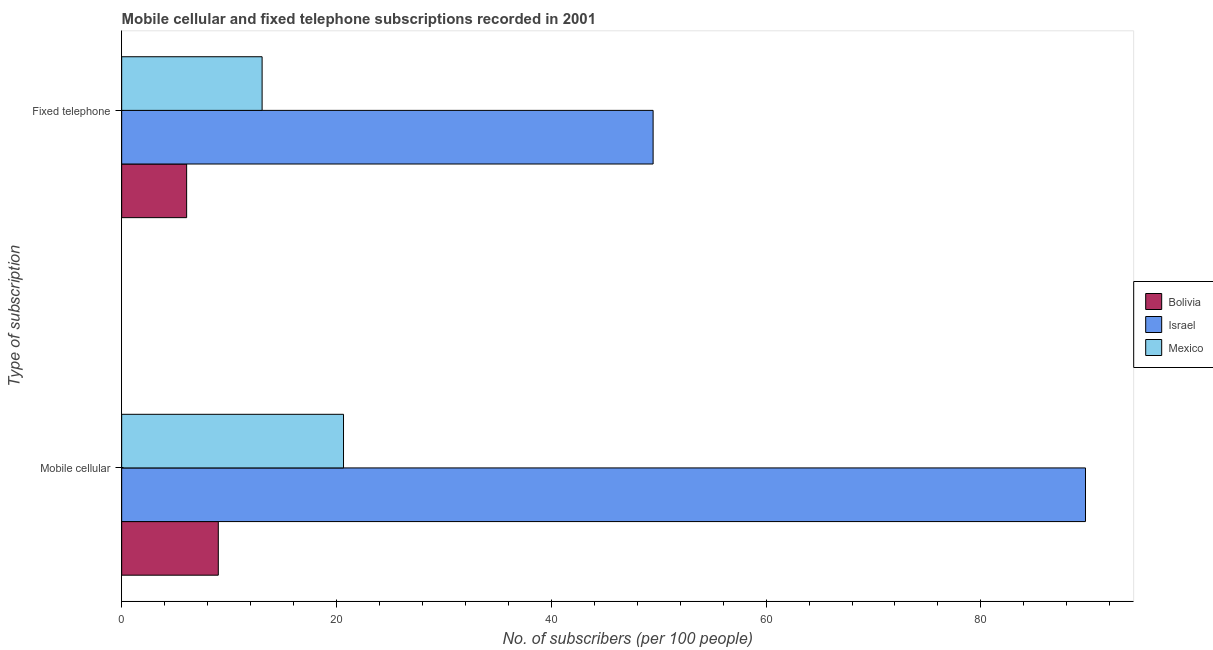How many groups of bars are there?
Your response must be concise. 2. Are the number of bars on each tick of the Y-axis equal?
Your answer should be compact. Yes. How many bars are there on the 1st tick from the top?
Offer a very short reply. 3. What is the label of the 2nd group of bars from the top?
Offer a terse response. Mobile cellular. What is the number of fixed telephone subscribers in Bolivia?
Provide a short and direct response. 6.05. Across all countries, what is the maximum number of fixed telephone subscribers?
Give a very brief answer. 49.48. Across all countries, what is the minimum number of mobile cellular subscribers?
Keep it short and to the point. 9. In which country was the number of fixed telephone subscribers maximum?
Your answer should be very brief. Israel. In which country was the number of fixed telephone subscribers minimum?
Make the answer very short. Bolivia. What is the total number of fixed telephone subscribers in the graph?
Your answer should be very brief. 68.61. What is the difference between the number of fixed telephone subscribers in Mexico and that in Israel?
Give a very brief answer. -36.41. What is the difference between the number of fixed telephone subscribers in Bolivia and the number of mobile cellular subscribers in Mexico?
Make the answer very short. -14.61. What is the average number of fixed telephone subscribers per country?
Your answer should be very brief. 22.87. What is the difference between the number of mobile cellular subscribers and number of fixed telephone subscribers in Israel?
Offer a very short reply. 40.26. What is the ratio of the number of fixed telephone subscribers in Bolivia to that in Israel?
Your answer should be compact. 0.12. What does the 1st bar from the top in Mobile cellular represents?
Offer a terse response. Mexico. What does the 3rd bar from the bottom in Fixed telephone represents?
Keep it short and to the point. Mexico. How many bars are there?
Offer a terse response. 6. Are all the bars in the graph horizontal?
Give a very brief answer. Yes. How many countries are there in the graph?
Ensure brevity in your answer.  3. What is the difference between two consecutive major ticks on the X-axis?
Your response must be concise. 20. What is the title of the graph?
Offer a very short reply. Mobile cellular and fixed telephone subscriptions recorded in 2001. Does "Arab World" appear as one of the legend labels in the graph?
Offer a terse response. No. What is the label or title of the X-axis?
Ensure brevity in your answer.  No. of subscribers (per 100 people). What is the label or title of the Y-axis?
Offer a terse response. Type of subscription. What is the No. of subscribers (per 100 people) in Bolivia in Mobile cellular?
Ensure brevity in your answer.  9. What is the No. of subscribers (per 100 people) of Israel in Mobile cellular?
Your answer should be compact. 89.74. What is the No. of subscribers (per 100 people) in Mexico in Mobile cellular?
Offer a terse response. 20.65. What is the No. of subscribers (per 100 people) of Bolivia in Fixed telephone?
Provide a succinct answer. 6.05. What is the No. of subscribers (per 100 people) in Israel in Fixed telephone?
Your answer should be compact. 49.48. What is the No. of subscribers (per 100 people) of Mexico in Fixed telephone?
Give a very brief answer. 13.08. Across all Type of subscription, what is the maximum No. of subscribers (per 100 people) in Bolivia?
Make the answer very short. 9. Across all Type of subscription, what is the maximum No. of subscribers (per 100 people) of Israel?
Provide a succinct answer. 89.74. Across all Type of subscription, what is the maximum No. of subscribers (per 100 people) in Mexico?
Provide a short and direct response. 20.65. Across all Type of subscription, what is the minimum No. of subscribers (per 100 people) in Bolivia?
Ensure brevity in your answer.  6.05. Across all Type of subscription, what is the minimum No. of subscribers (per 100 people) of Israel?
Offer a very short reply. 49.48. Across all Type of subscription, what is the minimum No. of subscribers (per 100 people) of Mexico?
Your answer should be very brief. 13.08. What is the total No. of subscribers (per 100 people) of Bolivia in the graph?
Make the answer very short. 15.05. What is the total No. of subscribers (per 100 people) in Israel in the graph?
Give a very brief answer. 139.22. What is the total No. of subscribers (per 100 people) of Mexico in the graph?
Make the answer very short. 33.73. What is the difference between the No. of subscribers (per 100 people) in Bolivia in Mobile cellular and that in Fixed telephone?
Provide a short and direct response. 2.95. What is the difference between the No. of subscribers (per 100 people) in Israel in Mobile cellular and that in Fixed telephone?
Offer a very short reply. 40.26. What is the difference between the No. of subscribers (per 100 people) of Mexico in Mobile cellular and that in Fixed telephone?
Your answer should be very brief. 7.58. What is the difference between the No. of subscribers (per 100 people) in Bolivia in Mobile cellular and the No. of subscribers (per 100 people) in Israel in Fixed telephone?
Ensure brevity in your answer.  -40.48. What is the difference between the No. of subscribers (per 100 people) in Bolivia in Mobile cellular and the No. of subscribers (per 100 people) in Mexico in Fixed telephone?
Provide a succinct answer. -4.08. What is the difference between the No. of subscribers (per 100 people) of Israel in Mobile cellular and the No. of subscribers (per 100 people) of Mexico in Fixed telephone?
Provide a succinct answer. 76.66. What is the average No. of subscribers (per 100 people) of Bolivia per Type of subscription?
Offer a terse response. 7.52. What is the average No. of subscribers (per 100 people) of Israel per Type of subscription?
Your response must be concise. 69.61. What is the average No. of subscribers (per 100 people) in Mexico per Type of subscription?
Offer a very short reply. 16.87. What is the difference between the No. of subscribers (per 100 people) in Bolivia and No. of subscribers (per 100 people) in Israel in Mobile cellular?
Make the answer very short. -80.74. What is the difference between the No. of subscribers (per 100 people) of Bolivia and No. of subscribers (per 100 people) of Mexico in Mobile cellular?
Provide a short and direct response. -11.66. What is the difference between the No. of subscribers (per 100 people) of Israel and No. of subscribers (per 100 people) of Mexico in Mobile cellular?
Provide a short and direct response. 69.08. What is the difference between the No. of subscribers (per 100 people) of Bolivia and No. of subscribers (per 100 people) of Israel in Fixed telephone?
Your answer should be very brief. -43.43. What is the difference between the No. of subscribers (per 100 people) of Bolivia and No. of subscribers (per 100 people) of Mexico in Fixed telephone?
Provide a short and direct response. -7.03. What is the difference between the No. of subscribers (per 100 people) of Israel and No. of subscribers (per 100 people) of Mexico in Fixed telephone?
Ensure brevity in your answer.  36.41. What is the ratio of the No. of subscribers (per 100 people) in Bolivia in Mobile cellular to that in Fixed telephone?
Give a very brief answer. 1.49. What is the ratio of the No. of subscribers (per 100 people) of Israel in Mobile cellular to that in Fixed telephone?
Provide a succinct answer. 1.81. What is the ratio of the No. of subscribers (per 100 people) in Mexico in Mobile cellular to that in Fixed telephone?
Offer a very short reply. 1.58. What is the difference between the highest and the second highest No. of subscribers (per 100 people) of Bolivia?
Offer a terse response. 2.95. What is the difference between the highest and the second highest No. of subscribers (per 100 people) in Israel?
Your response must be concise. 40.26. What is the difference between the highest and the second highest No. of subscribers (per 100 people) in Mexico?
Provide a short and direct response. 7.58. What is the difference between the highest and the lowest No. of subscribers (per 100 people) in Bolivia?
Offer a very short reply. 2.95. What is the difference between the highest and the lowest No. of subscribers (per 100 people) in Israel?
Your answer should be very brief. 40.26. What is the difference between the highest and the lowest No. of subscribers (per 100 people) of Mexico?
Your response must be concise. 7.58. 